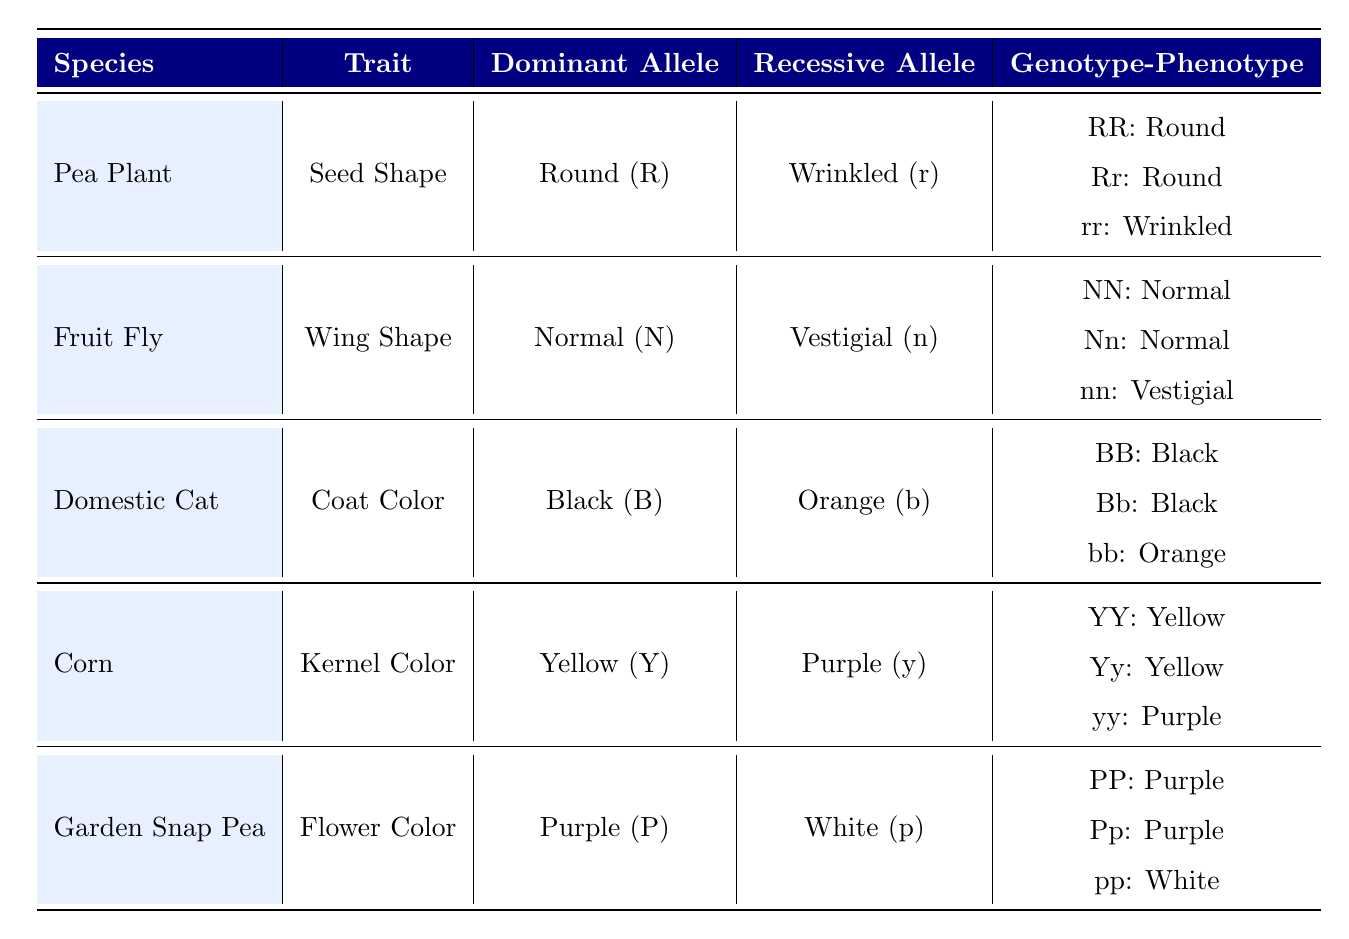What is the dominant allele for seed shape in Pea Plants? The table shows that the dominant allele for seed shape in Pea Plants is Round (R).
Answer: Round (R) Which phenotype corresponds to the genotype nn in Fruit Flies? Looking at the Fruit Fly section of the table, the genotype nn corresponds to the phenotype Vestigial.
Answer: Vestigial How many different genotypes are there for the trait Kernel Color in Corn? The table lists three genotypes for Kernel Color in Corn: YY, Yy, and yy, making a total of 3 genotypes.
Answer: 3 Is the phenotype for genotype Bb in Domestic Cats Black? Referring to the Domestic Cat section in the table, Bb corresponds to the phenotype Black, so the answer is yes.
Answer: Yes What percentage of the genotypes listed for Garden Snap Peas shows a purple phenotype? There are three genotypes for Garden Snap Peas: PP, Pp, and pp; both PP and Pp have the purple phenotype, making 2 out of 3 genotypes, which is approximately 66.67%.
Answer: 66.67% What is the recessive allele for coat color in Domestic Cats? The table indicates that the recessive allele for coat color in Domestic Cats is Orange (b).
Answer: Orange (b) For which species is the dominant allele for flower color purple? Looking at the table, the dominant allele for flower color (P) in Garden Snap Peas is purple, and it does not appear for any other species listed.
Answer: Garden Snap Pea What is the relationship between genotypes and phenotypes in terms of seed shape for Pea Plants? The table indicates that both genotypes RR and Rr result in the Round phenotype, while rr results in Wrinkled. This shows the dominance of the Round trait over the Wrinkled one.
Answer: Round dominates Wrinkled Which species has the recessive allele of purple kernel color? In the Corn section, the recessive allele for kernel color is Purple (y).
Answer: Purple (y) 